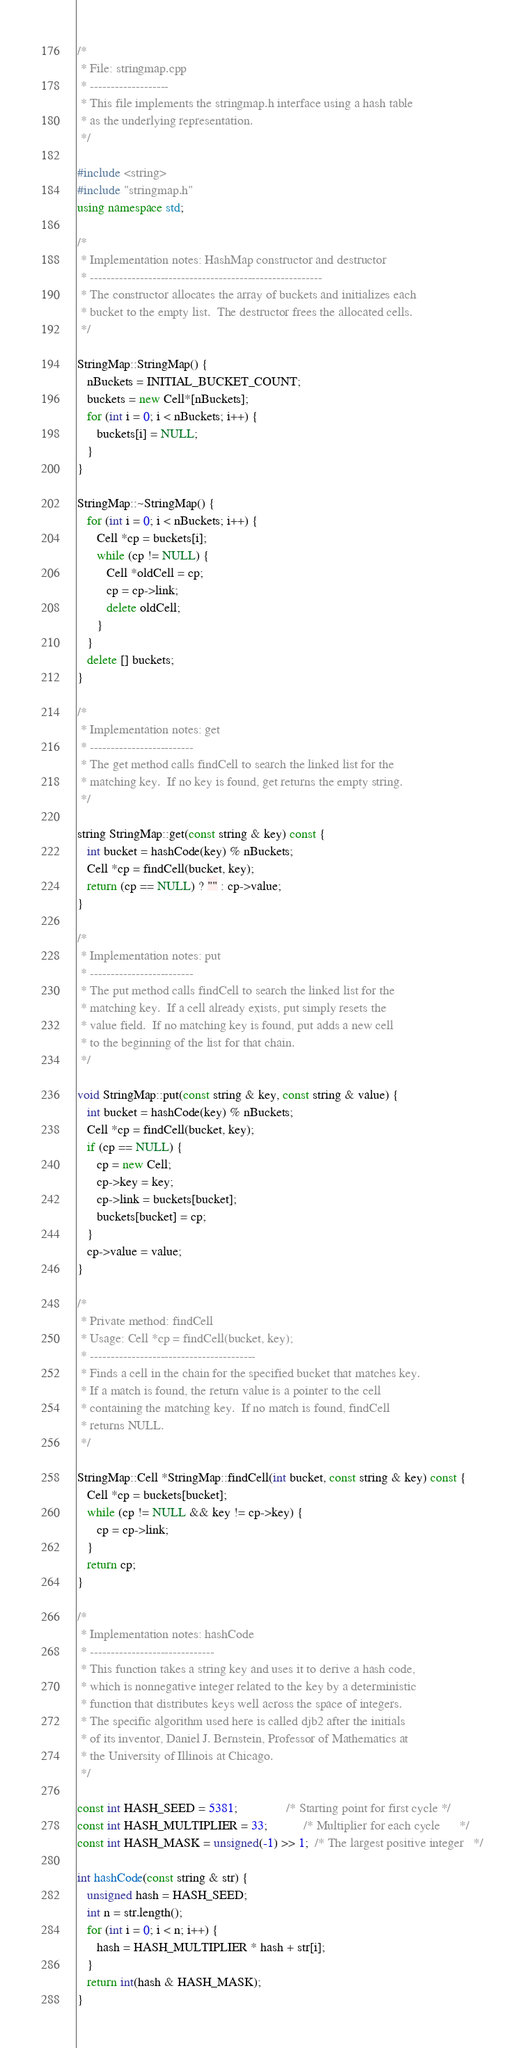<code> <loc_0><loc_0><loc_500><loc_500><_C++_>/*
 * File: stringmap.cpp
 * -------------------
 * This file implements the stringmap.h interface using a hash table
 * as the underlying representation.
 */

#include <string>
#include "stringmap.h"
using namespace std;

/*
 * Implementation notes: HashMap constructor and destructor
 * --------------------------------------------------------
 * The constructor allocates the array of buckets and initializes each
 * bucket to the empty list.  The destructor frees the allocated cells.
 */

StringMap::StringMap() {
   nBuckets = INITIAL_BUCKET_COUNT;
   buckets = new Cell*[nBuckets];
   for (int i = 0; i < nBuckets; i++) {
      buckets[i] = NULL;
   }
}

StringMap::~StringMap() {
   for (int i = 0; i < nBuckets; i++) {
      Cell *cp = buckets[i];
      while (cp != NULL) {
         Cell *oldCell = cp;
         cp = cp->link;
         delete oldCell;
      }
   }
   delete [] buckets;
}

/*
 * Implementation notes: get
 * -------------------------
 * The get method calls findCell to search the linked list for the
 * matching key.  If no key is found, get returns the empty string.
 */

string StringMap::get(const string & key) const {
   int bucket = hashCode(key) % nBuckets;
   Cell *cp = findCell(bucket, key);
   return (cp == NULL) ? "" : cp->value;
}

/*
 * Implementation notes: put
 * -------------------------
 * The put method calls findCell to search the linked list for the
 * matching key.  If a cell already exists, put simply resets the
 * value field.  If no matching key is found, put adds a new cell
 * to the beginning of the list for that chain.
 */

void StringMap::put(const string & key, const string & value) {
   int bucket = hashCode(key) % nBuckets;
   Cell *cp = findCell(bucket, key);
   if (cp == NULL) {
      cp = new Cell;
      cp->key = key;
      cp->link = buckets[bucket];
      buckets[bucket] = cp;
   }
   cp->value = value;
}

/*
 * Private method: findCell
 * Usage: Cell *cp = findCell(bucket, key);
 * ----------------------------------------
 * Finds a cell in the chain for the specified bucket that matches key.
 * If a match is found, the return value is a pointer to the cell
 * containing the matching key.  If no match is found, findCell
 * returns NULL.
 */

StringMap::Cell *StringMap::findCell(int bucket, const string & key) const {
   Cell *cp = buckets[bucket];
   while (cp != NULL && key != cp->key) {
      cp = cp->link;
   }
   return cp;
}

/*
 * Implementation notes: hashCode
 * ------------------------------
 * This function takes a string key and uses it to derive a hash code,
 * which is nonnegative integer related to the key by a deterministic
 * function that distributes keys well across the space of integers.
 * The specific algorithm used here is called djb2 after the initials
 * of its inventor, Daniel J. Bernstein, Professor of Mathematics at
 * the University of Illinois at Chicago.
 */

const int HASH_SEED = 5381;               /* Starting point for first cycle */
const int HASH_MULTIPLIER = 33;           /* Multiplier for each cycle      */
const int HASH_MASK = unsigned(-1) >> 1;  /* The largest positive integer   */

int hashCode(const string & str) {
   unsigned hash = HASH_SEED;
   int n = str.length();
   for (int i = 0; i < n; i++) {
      hash = HASH_MULTIPLIER * hash + str[i];
   }
   return int(hash & HASH_MASK);
}
</code> 